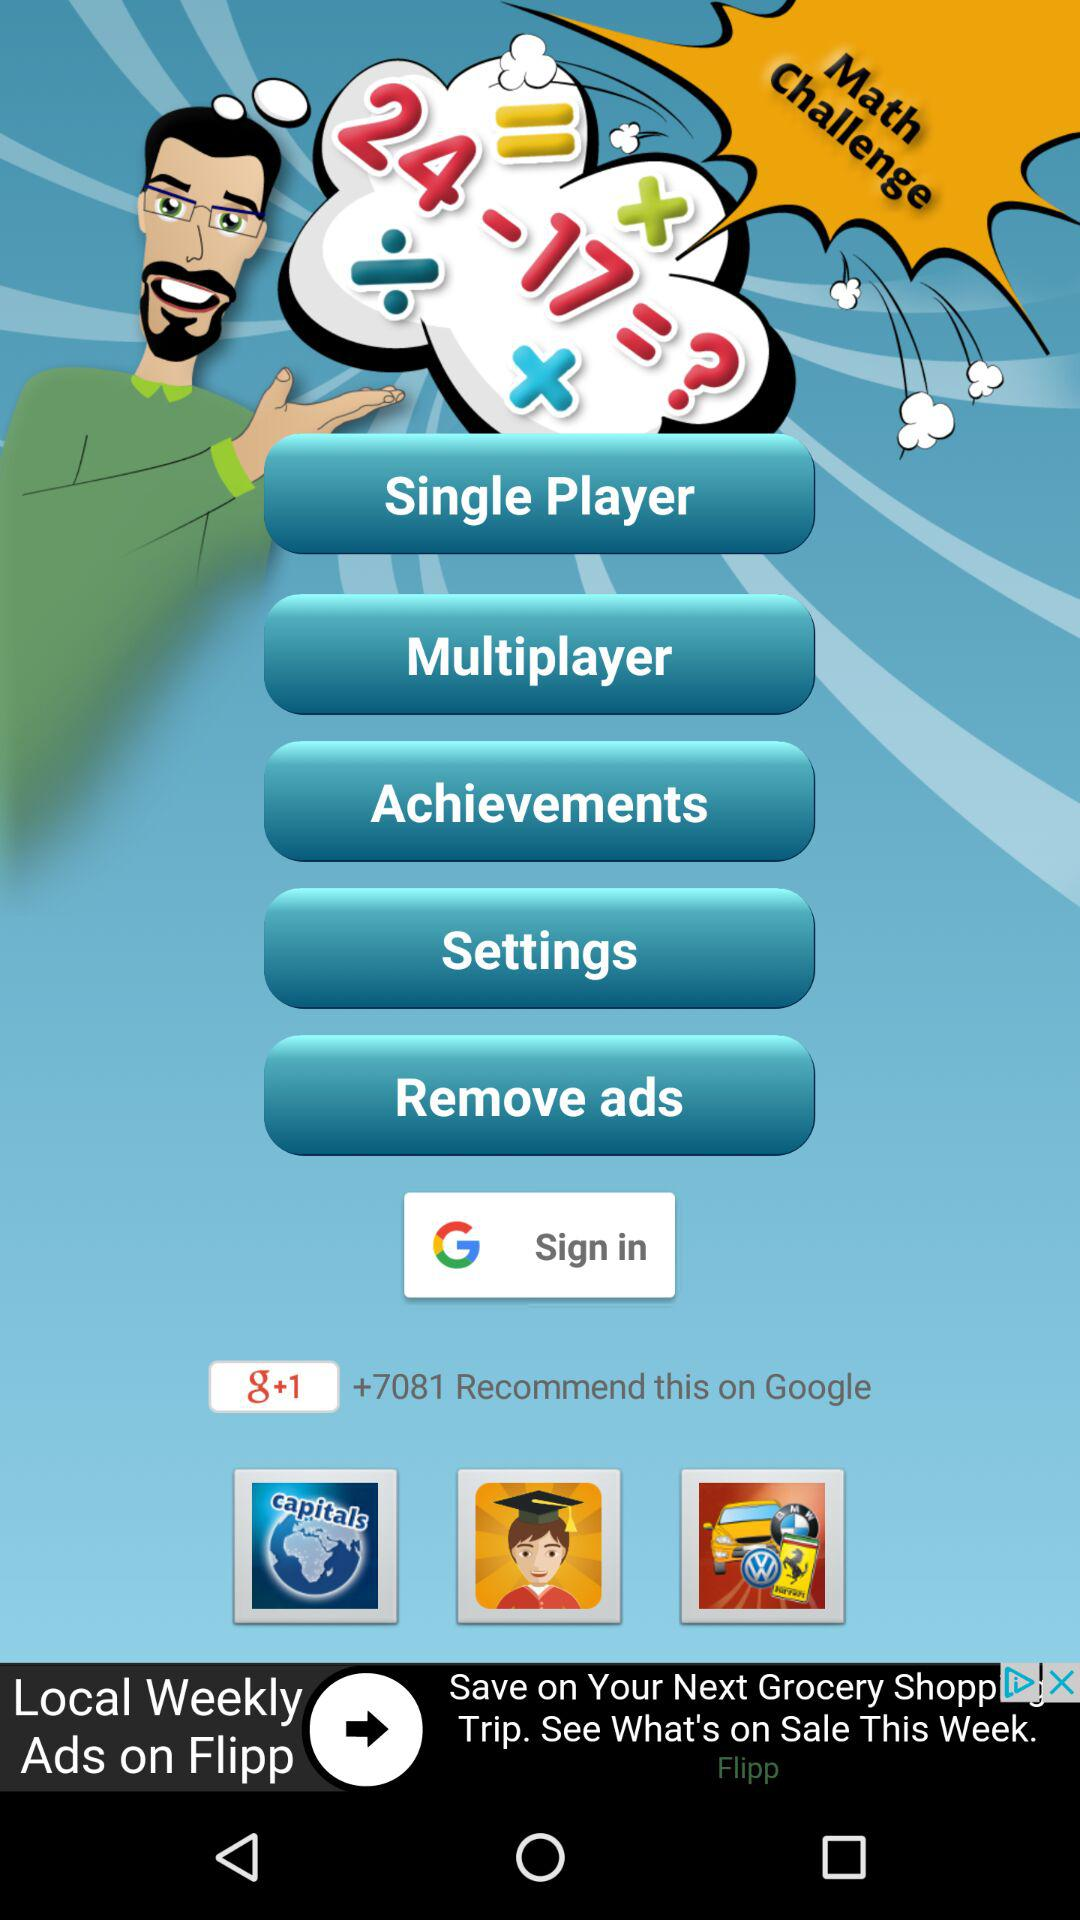What is the name of the application? The name of the application is "Math Challenge". 